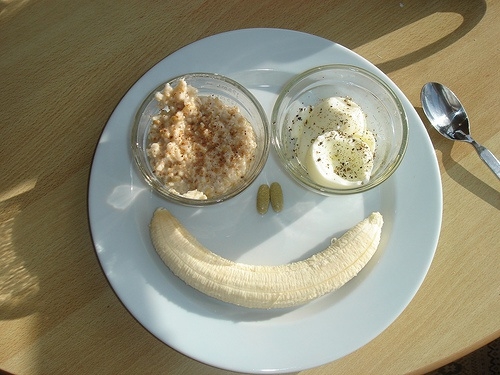Describe the objects in this image and their specific colors. I can see dining table in olive, darkgray, tan, lightgray, and gray tones, bowl in olive, tan, gray, and maroon tones, bowl in olive, darkgray, tan, ivory, and beige tones, banana in olive, beige, and tan tones, and spoon in olive, darkgray, gray, black, and white tones in this image. 